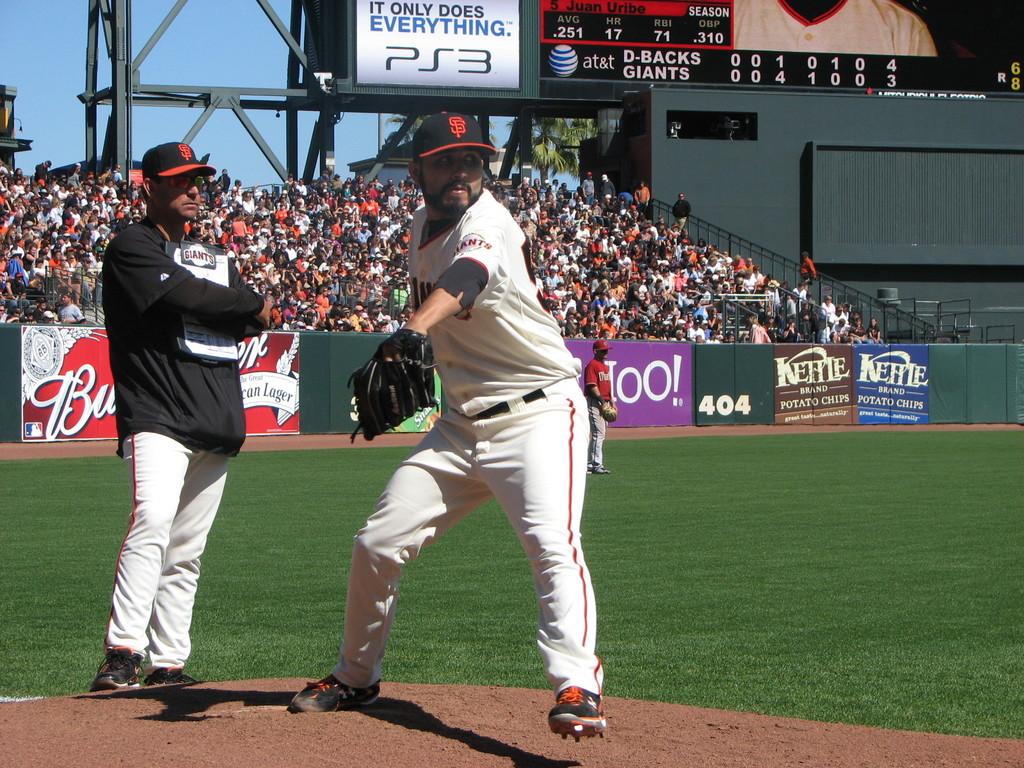What "does everything"?
Your response must be concise. Ps3. 